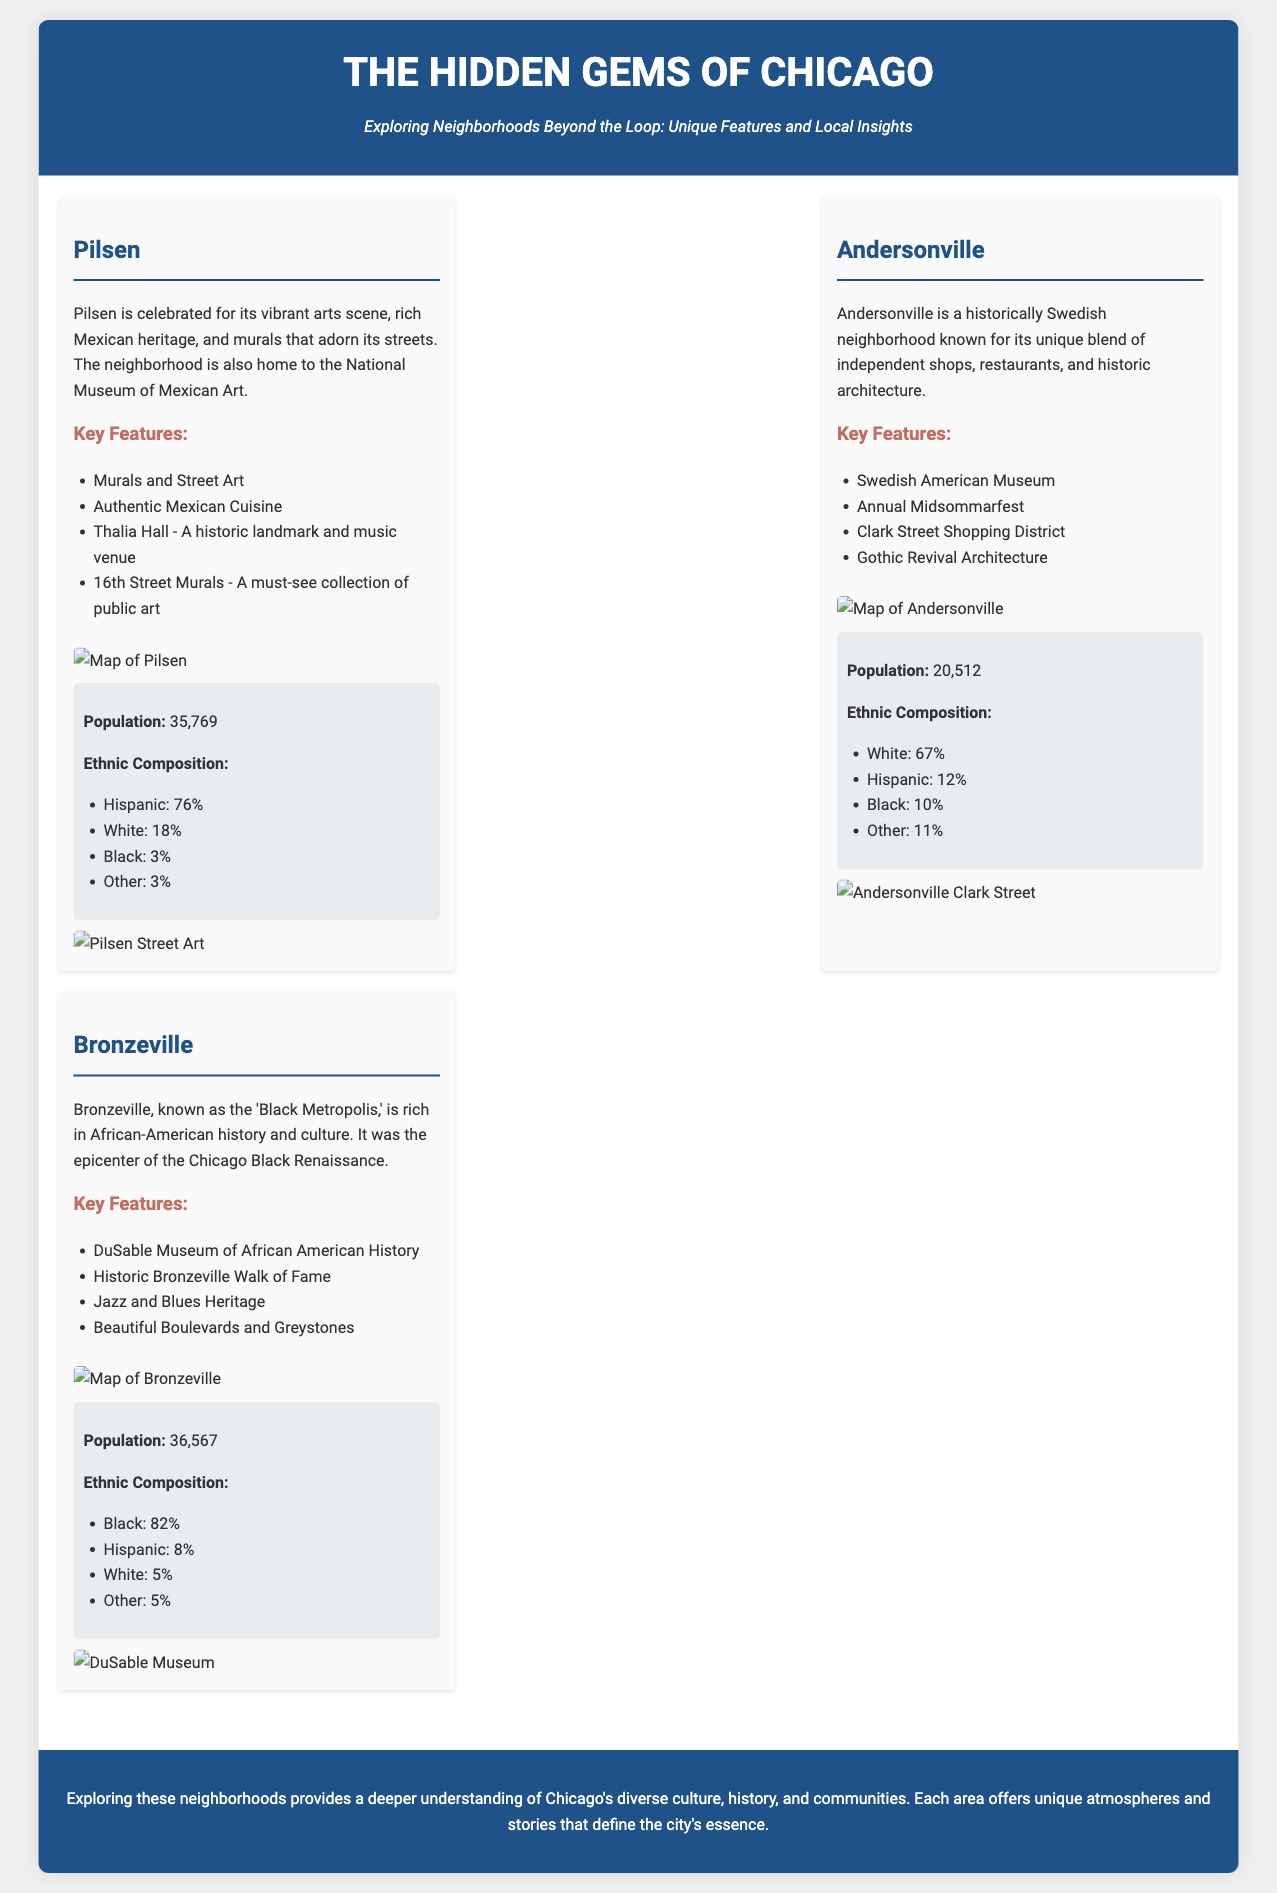What is the population of Pilsen? The population of Pilsen is explicitly stated as 35,769 in the demographics section.
Answer: 35,769 What percentage of Andersonville's population is White? The percentage of White residents in Andersonville is listed as 67% in the ethnic composition.
Answer: 67% What notable museum is located in Bronzeville? The document specifically mentions the DuSable Museum of African American History as a key feature of Bronzeville.
Answer: DuSable Museum of African American History What is the ethnic composition percentage of Black residents in Bronzeville? The document provides that 82% of the population in Bronzeville is Black according to the demographics section.
Answer: 82% Which neighborhood is known for its murals and street art? Pilsen is celebrated for its vibrant arts scene and street art, as highlighted in the neighborhood description.
Answer: Pilsen What annual festival is mentioned in Andersonville? The document notes the Annual Midsommarfest as one of Andersonville's key features.
Answer: Annual Midsommarfest How many neighborhoods are highlighted in the presentation? There are three neighborhoods detailed: Pilsen, Andersonville, and Bronzeville, as per the content structure.
Answer: Three What architectural style is notable in Andersonville? The presentation specifically mentions Gothic Revival Architecture as a key feature of Andersonville.
Answer: Gothic Revival Architecture What is the primary cultural influence in Pilsen? Pilsen is known for its rich Mexican heritage, which is a central theme in its description.
Answer: Mexican heritage 